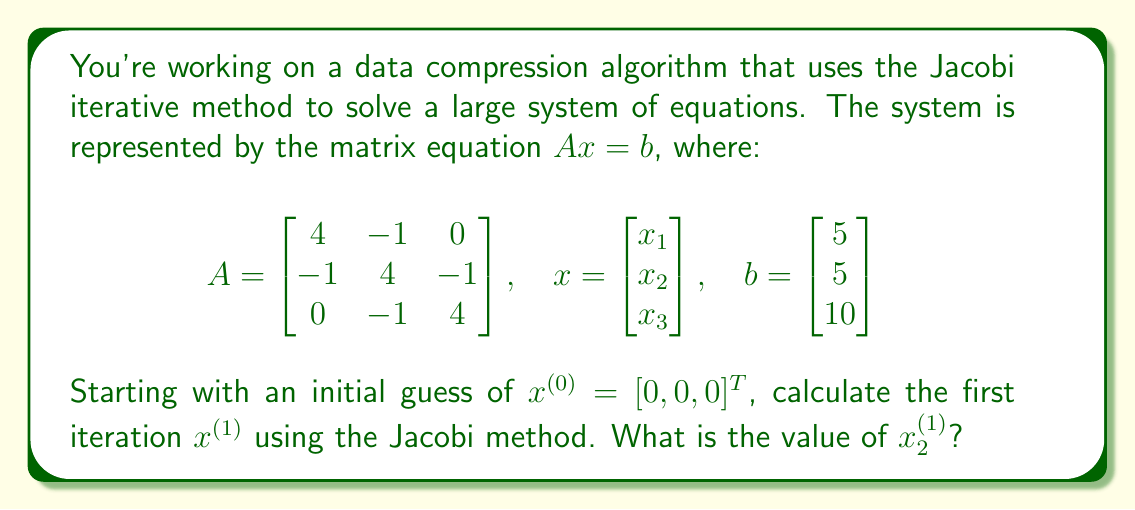Could you help me with this problem? To solve this problem using the Jacobi method, we'll follow these steps:

1) The Jacobi method for solving $Ax = b$ is given by the iteration formula:

   $x_i^{(k+1)} = \frac{1}{a_{ii}} (b_i - \sum_{j \neq i} a_{ij}x_j^{(k)})$

   where $k$ is the iteration number.

2) For our system, we have:

   $4x_1 - x_2 = 5$
   $-x_1 + 4x_2 - x_3 = 5$
   $-x_2 + 4x_3 = 10$

3) Applying the Jacobi method formula for each variable:

   $x_1^{(1)} = \frac{1}{4}(5 + x_2^{(0)})$
   $x_2^{(1)} = \frac{1}{4}(5 + x_1^{(0)} + x_3^{(0)})$
   $x_3^{(1)} = \frac{1}{4}(10 + x_2^{(0)})$

4) Given the initial guess $x^{(0)} = [0, 0, 0]^T$, we can calculate:

   $x_1^{(1)} = \frac{1}{4}(5 + 0) = 1.25$
   $x_2^{(1)} = \frac{1}{4}(5 + 0 + 0) = 1.25$
   $x_3^{(1)} = \frac{1}{4}(10 + 0) = 2.5$

5) Therefore, $x_2^{(1)} = 1.25$.
Answer: $1.25$ 